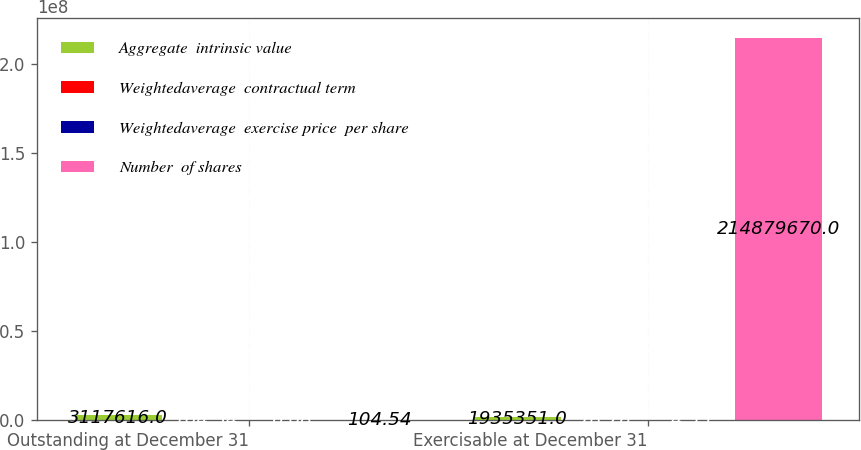Convert chart. <chart><loc_0><loc_0><loc_500><loc_500><stacked_bar_chart><ecel><fcel>Outstanding at December 31<fcel>Exercisable at December 31<nl><fcel>Aggregate  intrinsic value<fcel>3.11762e+06<fcel>1.93535e+06<nl><fcel>Weightedaverage  contractual term<fcel>104.54<fcel>78.76<nl><fcel>Weightedaverage  exercise price  per share<fcel>6.08<fcel>4.55<nl><fcel>Number  of shares<fcel>104.54<fcel>2.1488e+08<nl></chart> 